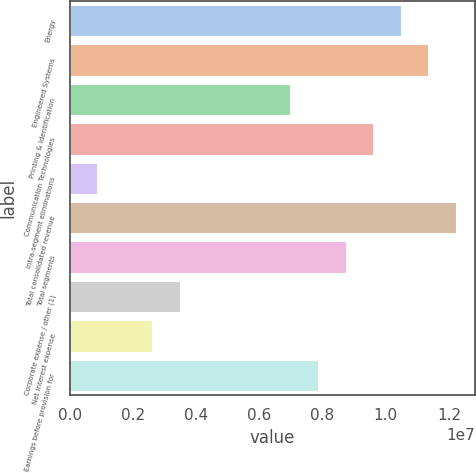Convert chart to OTSL. <chart><loc_0><loc_0><loc_500><loc_500><bar_chart><fcel>Energy<fcel>Engineered Systems<fcel>Printing & Identification<fcel>Communication Technologies<fcel>Intra-segment eliminations<fcel>Total consolidated revenue<fcel>Total segments<fcel>Corporate expense / other (1)<fcel>Net interest expense<fcel>Earnings before provision for<nl><fcel>1.04758e+07<fcel>1.13488e+07<fcel>6.98385e+06<fcel>9.60279e+06<fcel>872997<fcel>1.22217e+07<fcel>8.72981e+06<fcel>3.49194e+06<fcel>2.61896e+06<fcel>7.85683e+06<nl></chart> 